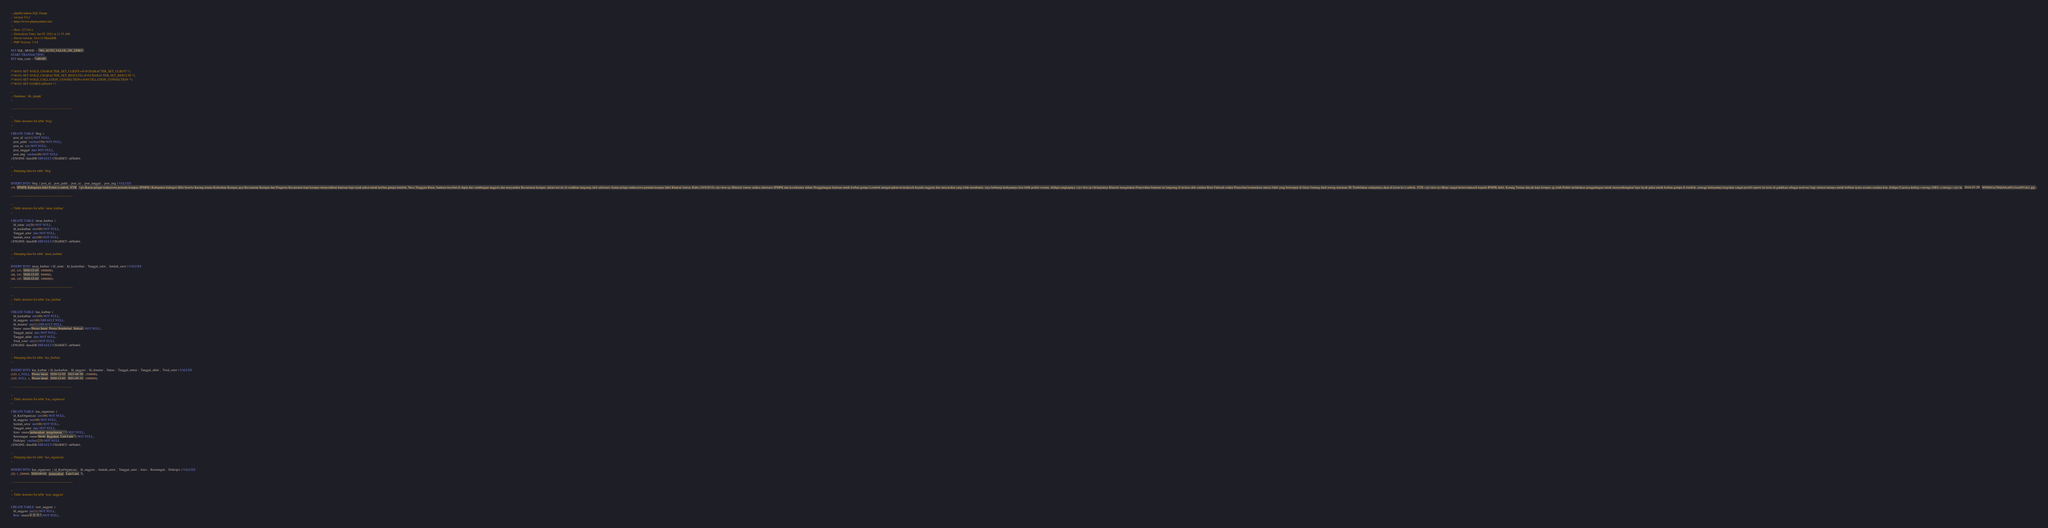Convert code to text. <code><loc_0><loc_0><loc_500><loc_500><_SQL_>-- phpMyAdmin SQL Dump
-- version 5.0.2
-- https://www.phpmyadmin.net/
--
-- Host: 127.0.0.1
-- Generation Time: Jan 05, 2021 at 11:33 AM
-- Server version: 10.4.13-MariaDB
-- PHP Version: 7.4.8

SET SQL_MODE = "NO_AUTO_VALUE_ON_ZERO";
START TRANSACTION;
SET time_zone = "+00:00";


/*!40101 SET @OLD_CHARACTER_SET_CLIENT=@@CHARACTER_SET_CLIENT */;
/*!40101 SET @OLD_CHARACTER_SET_RESULTS=@@CHARACTER_SET_RESULTS */;
/*!40101 SET @OLD_COLLATION_CONNECTION=@@COLLATION_CONNECTION */;
/*!40101 SET NAMES utf8mb4 */;

--
-- Database: `db_ipmpk`
--

-- --------------------------------------------------------

--
-- Table structure for table `blog`
--

CREATE TABLE `blog` (
  `post_id` int(11) NOT NULL,
  `post_judul` varchar(150) NOT NULL,
  `post_isi` text NOT NULL,
  `post_tanggal` date NOT NULL,
  `post_img` varchar(40) NOT NULL
) ENGINE=InnoDB DEFAULT CHARSET=utf8mb4;

--
-- Dumping data for table `blog`
--

INSERT INTO `blog` (`post_id`, `post_judul`, `post_isi`, `post_tanggal`, `post_img`) VALUES
(18, 'IPMPK Kabupaten Inhil Peduli Lombok, NTB', '<p>Ikatan pelajar mahasiswa pemuda kempas (IPMPK) Kabupaten Indragiri Hilir beserta Karang taruna Kelurahan Kempas jaya Kecamatan Kempas dan Pengurus Kecamatan knpi kempas menyerahkan bantuan baju layak pakai untuk korban gempa lombok, Nusa Tenggara Barat, bantuan tersebut di dapat dari sumbangan anggota dan masyarakat Kecamatan kempas, dalam hal ini di serahkan langsung oleh sekretaris ikatan pelajar mahasiswa pemuda kempas Inhil Khairul Anwar. Rabu (29/8/2018)</p>\n\n<p>Khairul Anwar selaku sekretaris IPMPK dan koordinator dalam Penggalangan bantuan untuk korban gempa Lombok mengucapkan terimakasih kepada anggota dan masyarakat yang telah membantu, saya berharap kedepannya kita lebih peduli sesama, &ldquo;ungkapnya.</p>\n\n<p>Selanjutnya Khairul mengatakan Penyerahan bantuan ini langsung di terima oleh saudara Roni Fahriadi selaku Penasehat komunikasi musisi Inhil yang bertempat di Jalan Gunung daek lorong mataram III Tembilahan selanjutnya akan di kirim ke Lombok, NTB.</p>\n\n<p>Bliau sangat berterimakasih kepada IPMPK Inhil, Karang Taruna dan pk knpi kempas yg telah Peduli melakukan penggalangan untuk menyumbangkan baju layak pakai untuk korban gempa di lombok, semoga kedepannya kegiatan sangat positif seperti ini terus di galakkan sebagai motivasi bagi elemen lainnya untuk berbuat nyata sesama saudara kita. &ldquo;Ujarnya.&nbsp;<strong>[HD].</strong></p>\n', '2018-07-29', '909f66f4a780dcb6ca09141ee69f1da1.jpg');

-- --------------------------------------------------------

--
-- Table structure for table `iuran_kurban`
--

CREATE TABLE `iuran_kurban` (
  `Id_iuran` int(20) NOT NULL,
  `Id_kaskurban` int(100) NOT NULL,
  `Tanggal_setor` date NOT NULL,
  `Jumlah_setor` int(100) NOT NULL
) ENGINE=InnoDB DEFAULT CHARSET=utf8mb4;

--
-- Dumping data for table `iuran_kurban`
--

INSERT INTO `iuran_kurban` (`Id_iuran`, `Id_kaskurban`, `Tanggal_setor`, `Jumlah_setor`) VALUES
(45, 143, '2020-12-03', 1000000),
(46, 143, '2020-12-07', 500000),
(48, 145, '2020-12-01', 1000000);

-- --------------------------------------------------------

--
-- Table structure for table `kas_kurban`
--

CREATE TABLE `kas_kurban` (
  `Id_kaskurban` int(100) NOT NULL,
  `Id_anggota` int(100) DEFAULT NULL,
  `Id_donatur` int(11) DEFAULT NULL,
  `Status` enum('Proses Iuran','Proses Pembelian','Selesai') NOT NULL,
  `Tanggal_mulai` date NOT NULL,
  `Tanggal_akhir` date NOT NULL,
  `Total_setor` int(11) NOT NULL
) ENGINE=InnoDB DEFAULT CHARSET=utf8mb4;

--
-- Dumping data for table `kas_kurban`
--

INSERT INTO `kas_kurban` (`Id_kaskurban`, `Id_anggota`, `Id_donatur`, `Status`, `Tanggal_mulai`, `Tanggal_akhir`, `Total_setor`) VALUES
(143, 1, NULL, 'Proses Iuran', '2020-12-02', '2021-06-30', 1500000),
(145, NULL, 1, 'Proses Iuran', '2020-12-01', '2021-05-31', 1000000);

-- --------------------------------------------------------

--
-- Table structure for table `kas_organisasi`
--

CREATE TABLE `kas_organisasi` (
  `id_KasOrganisasi` int(100) NOT NULL,
  `Id_anggota` int(100) NOT NULL,
  `Jumlah_setor` int(100) NOT NULL,
  `Tanggal_setor` date NOT NULL,
  `Jenis` enum('pemasukan','pengeluaran','','') NOT NULL,
  `Keterangan` enum('Iuran','Kegiatan','Lain Lain','') NOT NULL,
  `Diskripsi` varchar(225) NOT NULL
) ENGINE=InnoDB DEFAULT CHARSET=utf8mb4;

--
-- Dumping data for table `kas_organisasi`
--

INSERT INTO `kas_organisasi` (`id_KasOrganisasi`, `Id_anggota`, `Jumlah_setor`, `Tanggal_setor`, `Jenis`, `Keterangan`, `Diskripsi`) VALUES
(20, 1, 200000, '2020-09-01', 'pemasukan', 'Lain Lain', '');

-- --------------------------------------------------------

--
-- Table structure for table `user_anggota`
--

CREATE TABLE `user_anggota` (
  `Id_anggota` int(11) NOT NULL,
  `Role` enum('1','2','3','') NOT NULL,</code> 